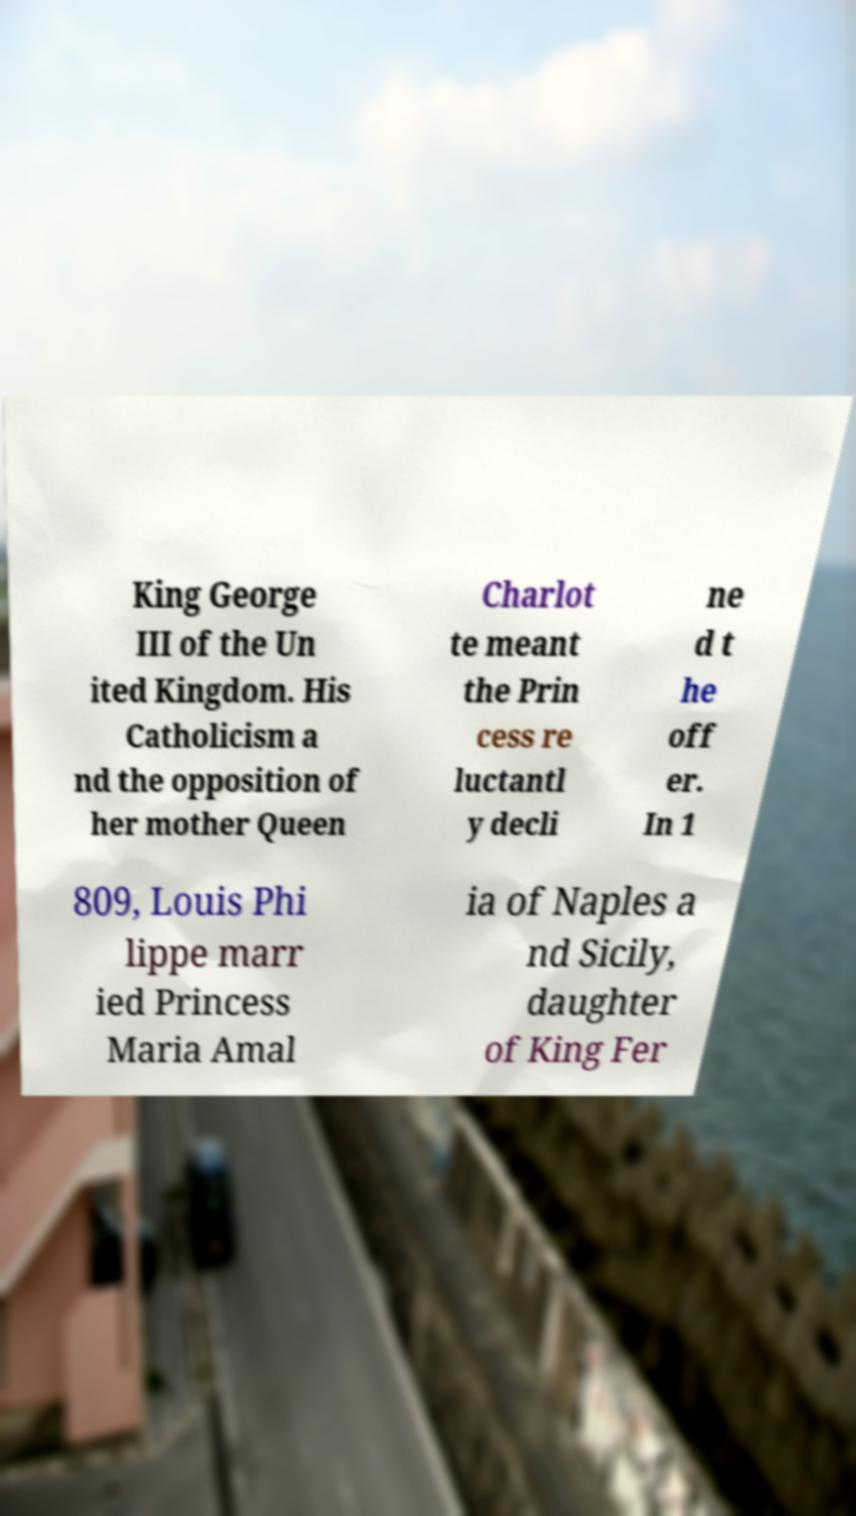There's text embedded in this image that I need extracted. Can you transcribe it verbatim? King George III of the Un ited Kingdom. His Catholicism a nd the opposition of her mother Queen Charlot te meant the Prin cess re luctantl y decli ne d t he off er. In 1 809, Louis Phi lippe marr ied Princess Maria Amal ia of Naples a nd Sicily, daughter of King Fer 